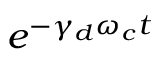Convert formula to latex. <formula><loc_0><loc_0><loc_500><loc_500>e ^ { - \gamma _ { d } \omega _ { c } t }</formula> 